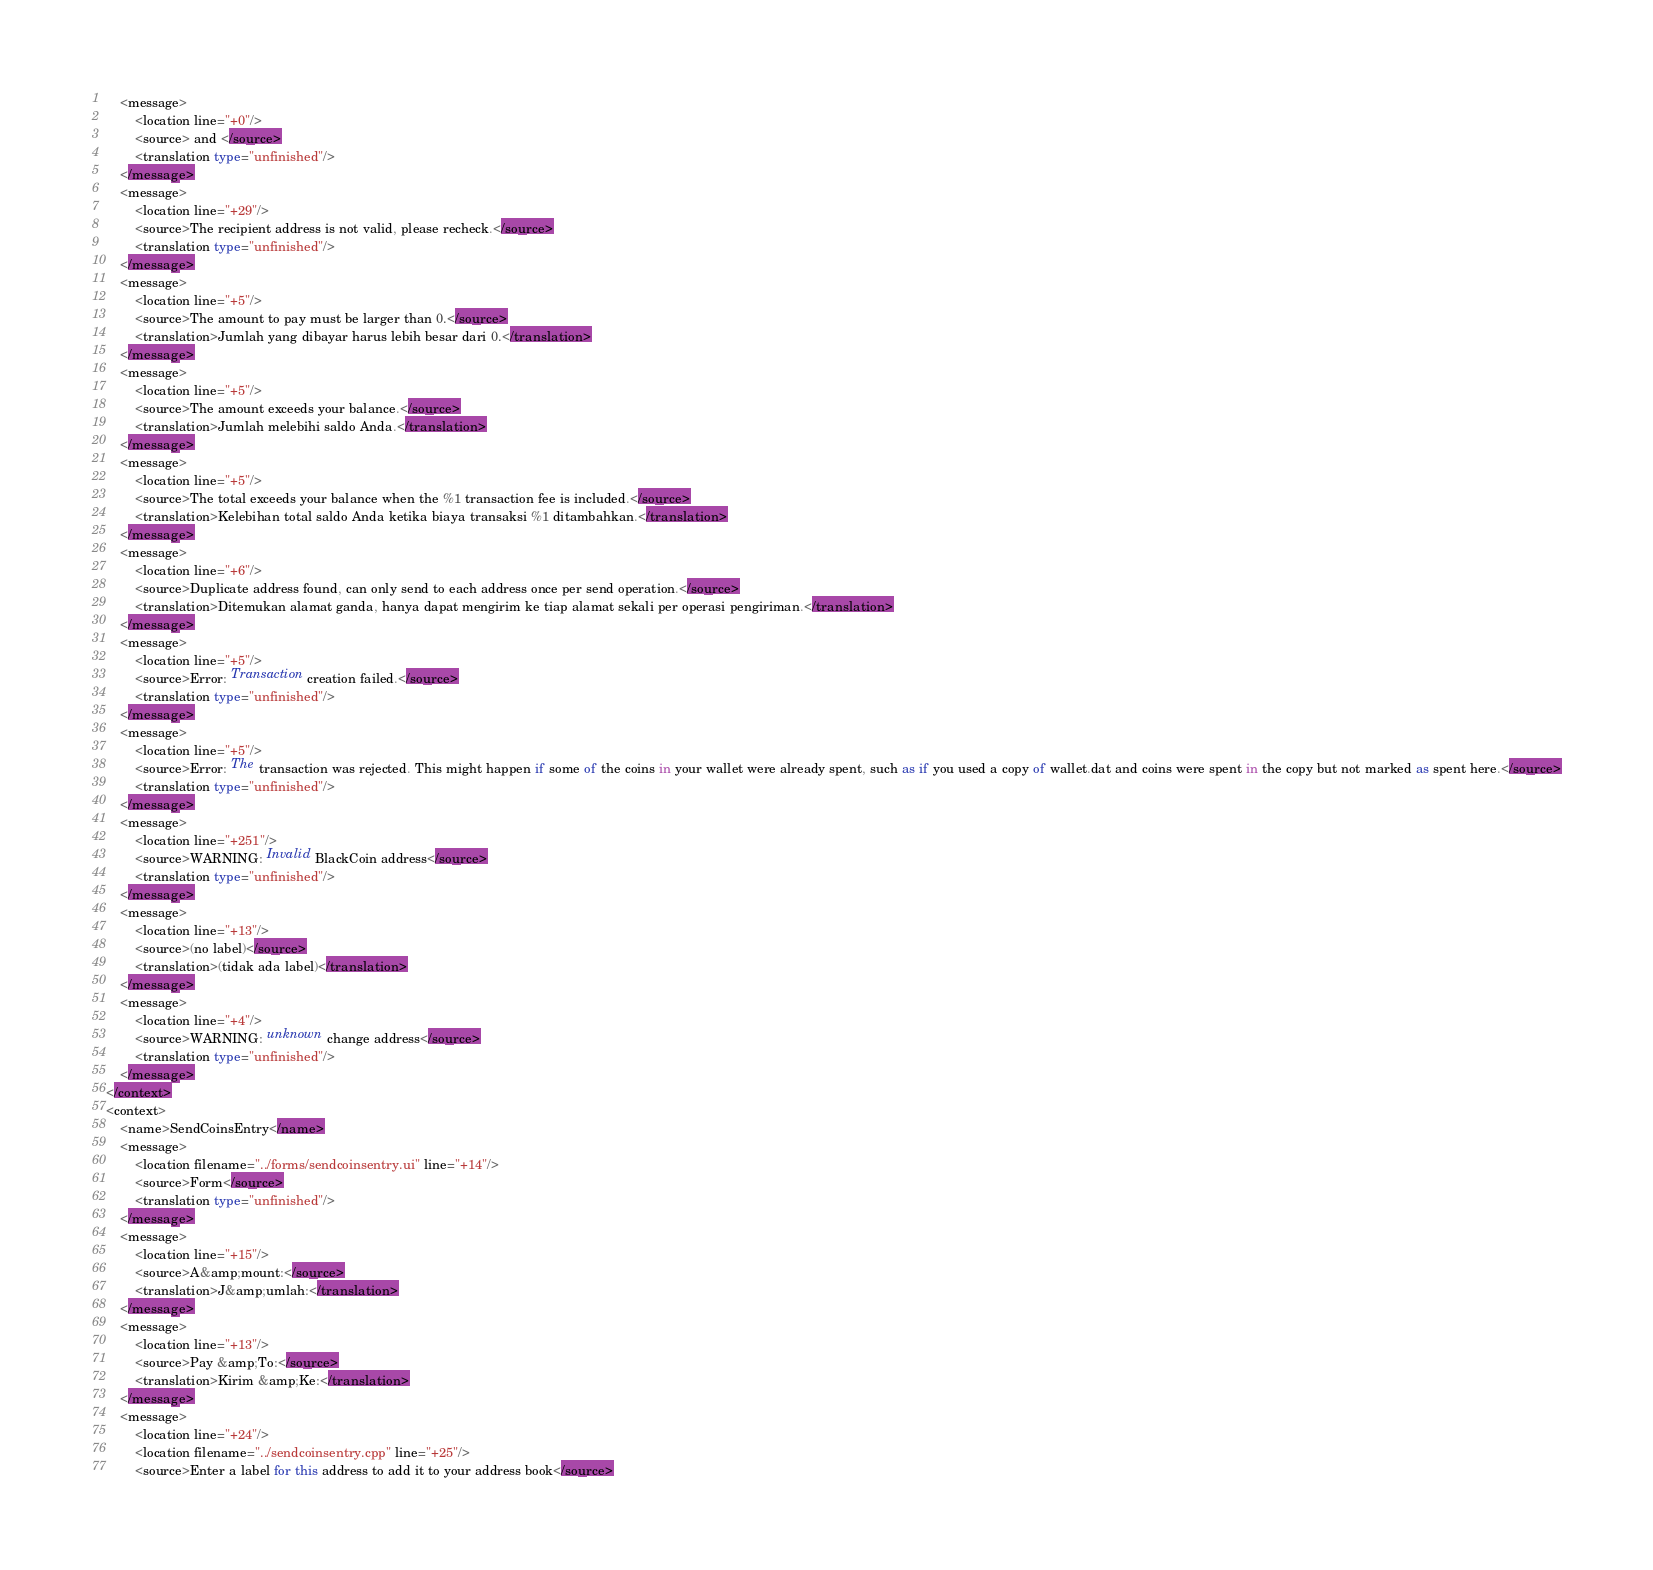<code> <loc_0><loc_0><loc_500><loc_500><_TypeScript_>    <message>
        <location line="+0"/>
        <source> and </source>
        <translation type="unfinished"/>
    </message>
    <message>
        <location line="+29"/>
        <source>The recipient address is not valid, please recheck.</source>
        <translation type="unfinished"/>
    </message>
    <message>
        <location line="+5"/>
        <source>The amount to pay must be larger than 0.</source>
        <translation>Jumlah yang dibayar harus lebih besar dari 0.</translation>
    </message>
    <message>
        <location line="+5"/>
        <source>The amount exceeds your balance.</source>
        <translation>Jumlah melebihi saldo Anda.</translation>
    </message>
    <message>
        <location line="+5"/>
        <source>The total exceeds your balance when the %1 transaction fee is included.</source>
        <translation>Kelebihan total saldo Anda ketika biaya transaksi %1 ditambahkan.</translation>
    </message>
    <message>
        <location line="+6"/>
        <source>Duplicate address found, can only send to each address once per send operation.</source>
        <translation>Ditemukan alamat ganda, hanya dapat mengirim ke tiap alamat sekali per operasi pengiriman.</translation>
    </message>
    <message>
        <location line="+5"/>
        <source>Error: Transaction creation failed.</source>
        <translation type="unfinished"/>
    </message>
    <message>
        <location line="+5"/>
        <source>Error: The transaction was rejected. This might happen if some of the coins in your wallet were already spent, such as if you used a copy of wallet.dat and coins were spent in the copy but not marked as spent here.</source>
        <translation type="unfinished"/>
    </message>
    <message>
        <location line="+251"/>
        <source>WARNING: Invalid BlackCoin address</source>
        <translation type="unfinished"/>
    </message>
    <message>
        <location line="+13"/>
        <source>(no label)</source>
        <translation>(tidak ada label)</translation>
    </message>
    <message>
        <location line="+4"/>
        <source>WARNING: unknown change address</source>
        <translation type="unfinished"/>
    </message>
</context>
<context>
    <name>SendCoinsEntry</name>
    <message>
        <location filename="../forms/sendcoinsentry.ui" line="+14"/>
        <source>Form</source>
        <translation type="unfinished"/>
    </message>
    <message>
        <location line="+15"/>
        <source>A&amp;mount:</source>
        <translation>J&amp;umlah:</translation>
    </message>
    <message>
        <location line="+13"/>
        <source>Pay &amp;To:</source>
        <translation>Kirim &amp;Ke:</translation>
    </message>
    <message>
        <location line="+24"/>
        <location filename="../sendcoinsentry.cpp" line="+25"/>
        <source>Enter a label for this address to add it to your address book</source></code> 